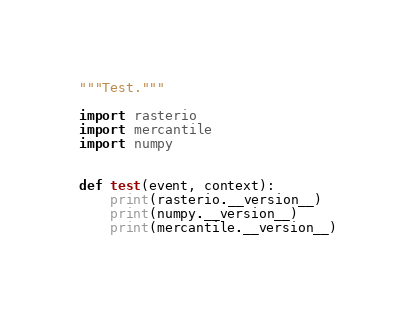Convert code to text. <code><loc_0><loc_0><loc_500><loc_500><_Python_>"""Test."""

import rasterio
import mercantile
import numpy


def test(event, context):
    print(rasterio.__version__)
    print(numpy.__version__)
    print(mercantile.__version__)
</code> 